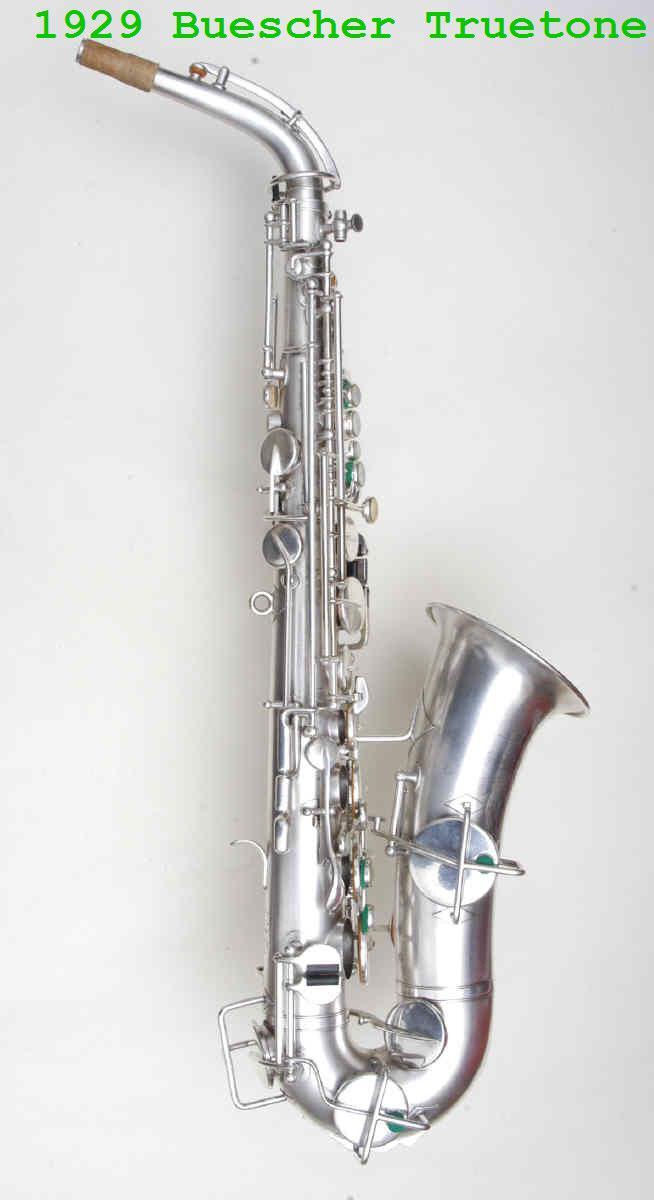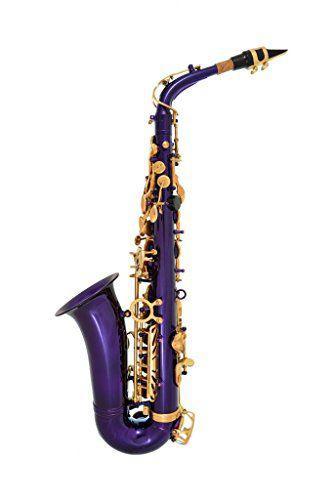The first image is the image on the left, the second image is the image on the right. Analyze the images presented: Is the assertion "Each image shows a saxophone with an upturned bell, and one image features a violet-blue saxophone." valid? Answer yes or no. Yes. 